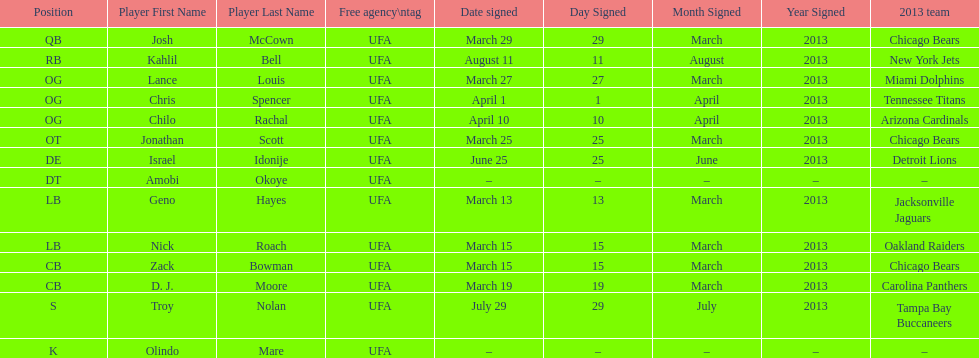Who was the previous player signed before troy nolan? Israel Idonije. Give me the full table as a dictionary. {'header': ['Position', 'Player First Name', 'Player Last Name', 'Free agency\\ntag', 'Date signed', 'Day Signed', 'Month Signed', 'Year Signed', '2013 team'], 'rows': [['QB', 'Josh', 'McCown', 'UFA', 'March 29', '29', 'March', '2013', 'Chicago Bears'], ['RB', 'Kahlil', 'Bell', 'UFA', 'August 11', '11', 'August', '2013', 'New York Jets'], ['OG', 'Lance', 'Louis', 'UFA', 'March 27', '27', 'March', '2013', 'Miami Dolphins'], ['OG', 'Chris', 'Spencer', 'UFA', 'April 1', '1', 'April', '2013', 'Tennessee Titans'], ['OG', 'Chilo', 'Rachal', 'UFA', 'April 10', '10', 'April', '2013', 'Arizona Cardinals'], ['OT', 'Jonathan', 'Scott', 'UFA', 'March 25', '25', 'March', '2013', 'Chicago Bears'], ['DE', 'Israel', 'Idonije', 'UFA', 'June 25', '25', 'June', '2013', 'Detroit Lions'], ['DT', 'Amobi', 'Okoye', 'UFA', '–', '–', '–', '–', '–'], ['LB', 'Geno', 'Hayes', 'UFA', 'March 13', '13', 'March', '2013', 'Jacksonville Jaguars'], ['LB', 'Nick', 'Roach', 'UFA', 'March 15', '15', 'March', '2013', 'Oakland Raiders'], ['CB', 'Zack', 'Bowman', 'UFA', 'March 15', '15', 'March', '2013', 'Chicago Bears'], ['CB', 'D. J.', 'Moore', 'UFA', 'March 19', '19', 'March', '2013', 'Carolina Panthers'], ['S', 'Troy', 'Nolan', 'UFA', 'July 29', '29', 'July', '2013', 'Tampa Bay Buccaneers'], ['K', 'Olindo', 'Mare', 'UFA', '–', '–', '–', '–', '–']]} 